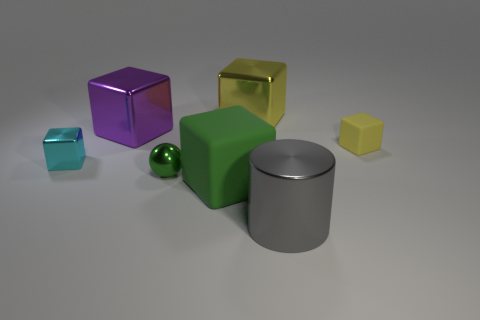Do the tiny object left of the small green thing and the large rubber thing have the same color?
Offer a very short reply. No. How many shiny things are yellow objects or big yellow blocks?
Your response must be concise. 1. Is there any other thing that is the same size as the green rubber object?
Ensure brevity in your answer.  Yes. What color is the sphere that is made of the same material as the gray thing?
Provide a succinct answer. Green. What number of cubes are small gray rubber objects or purple objects?
Provide a short and direct response. 1. How many objects are small purple blocks or rubber blocks that are in front of the tiny cyan object?
Keep it short and to the point. 1. Are any yellow rubber things visible?
Your answer should be compact. Yes. How many big shiny cylinders are the same color as the small metal block?
Keep it short and to the point. 0. What material is the large object that is the same color as the small metal sphere?
Offer a terse response. Rubber. What is the size of the green thing on the right side of the tiny metallic object in front of the tiny cyan metallic object?
Provide a short and direct response. Large. 